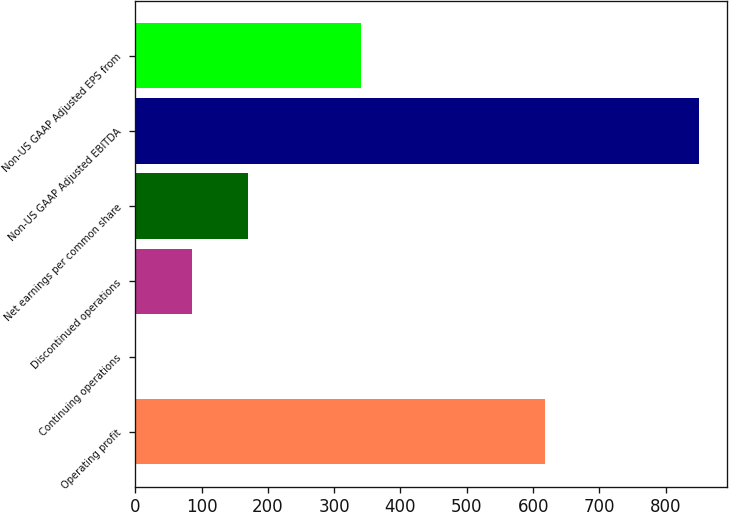Convert chart to OTSL. <chart><loc_0><loc_0><loc_500><loc_500><bar_chart><fcel>Operating profit<fcel>Continuing operations<fcel>Discontinued operations<fcel>Net earnings per common share<fcel>Non-US GAAP Adjusted EBITDA<fcel>Non-US GAAP Adjusted EPS from<nl><fcel>617.4<fcel>0.78<fcel>85.71<fcel>170.64<fcel>850.1<fcel>340.5<nl></chart> 